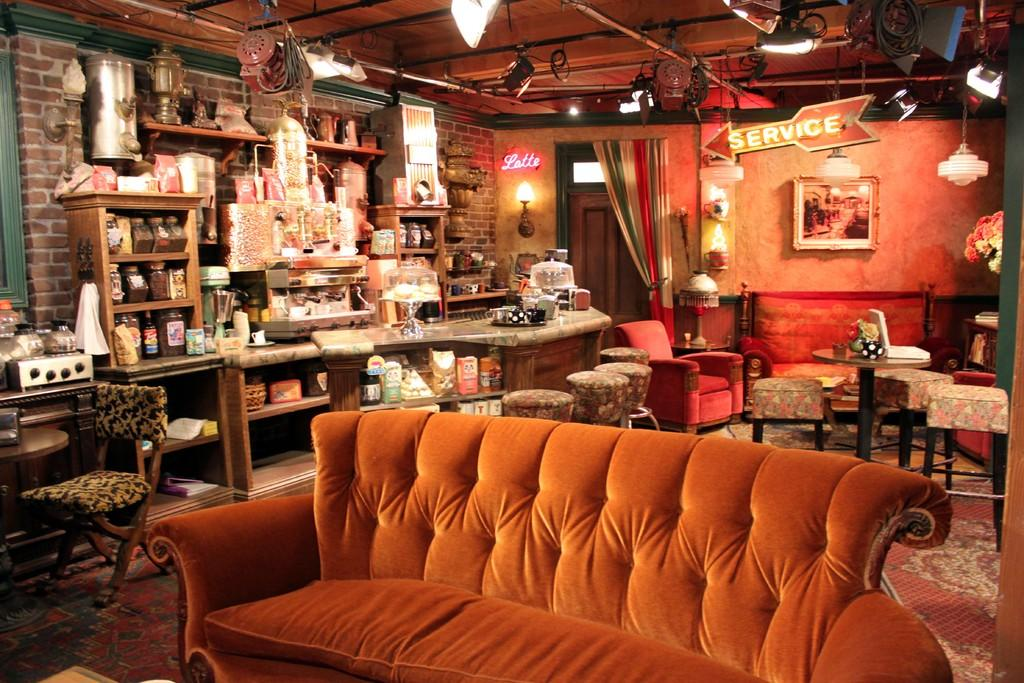What type of setting is depicted in the image? The image is an indoor scene. What theme or activity is related to the objects in the image? There are objects related to a race in the image. What color is the couch in the image? The couch in the image is orange. How far away from the couch are the chairs in the image? The chairs in the image are far from the couch. What type of lighting is visible in the image? There are lights visible in the image, presumably on the ceiling or wall. What is hanging on the wall in the image? There is a picture on the wall. What type of shirt is the slave wearing in the image? There is no slave or shirt present in the image. The image does not depict any people or clothing items. 